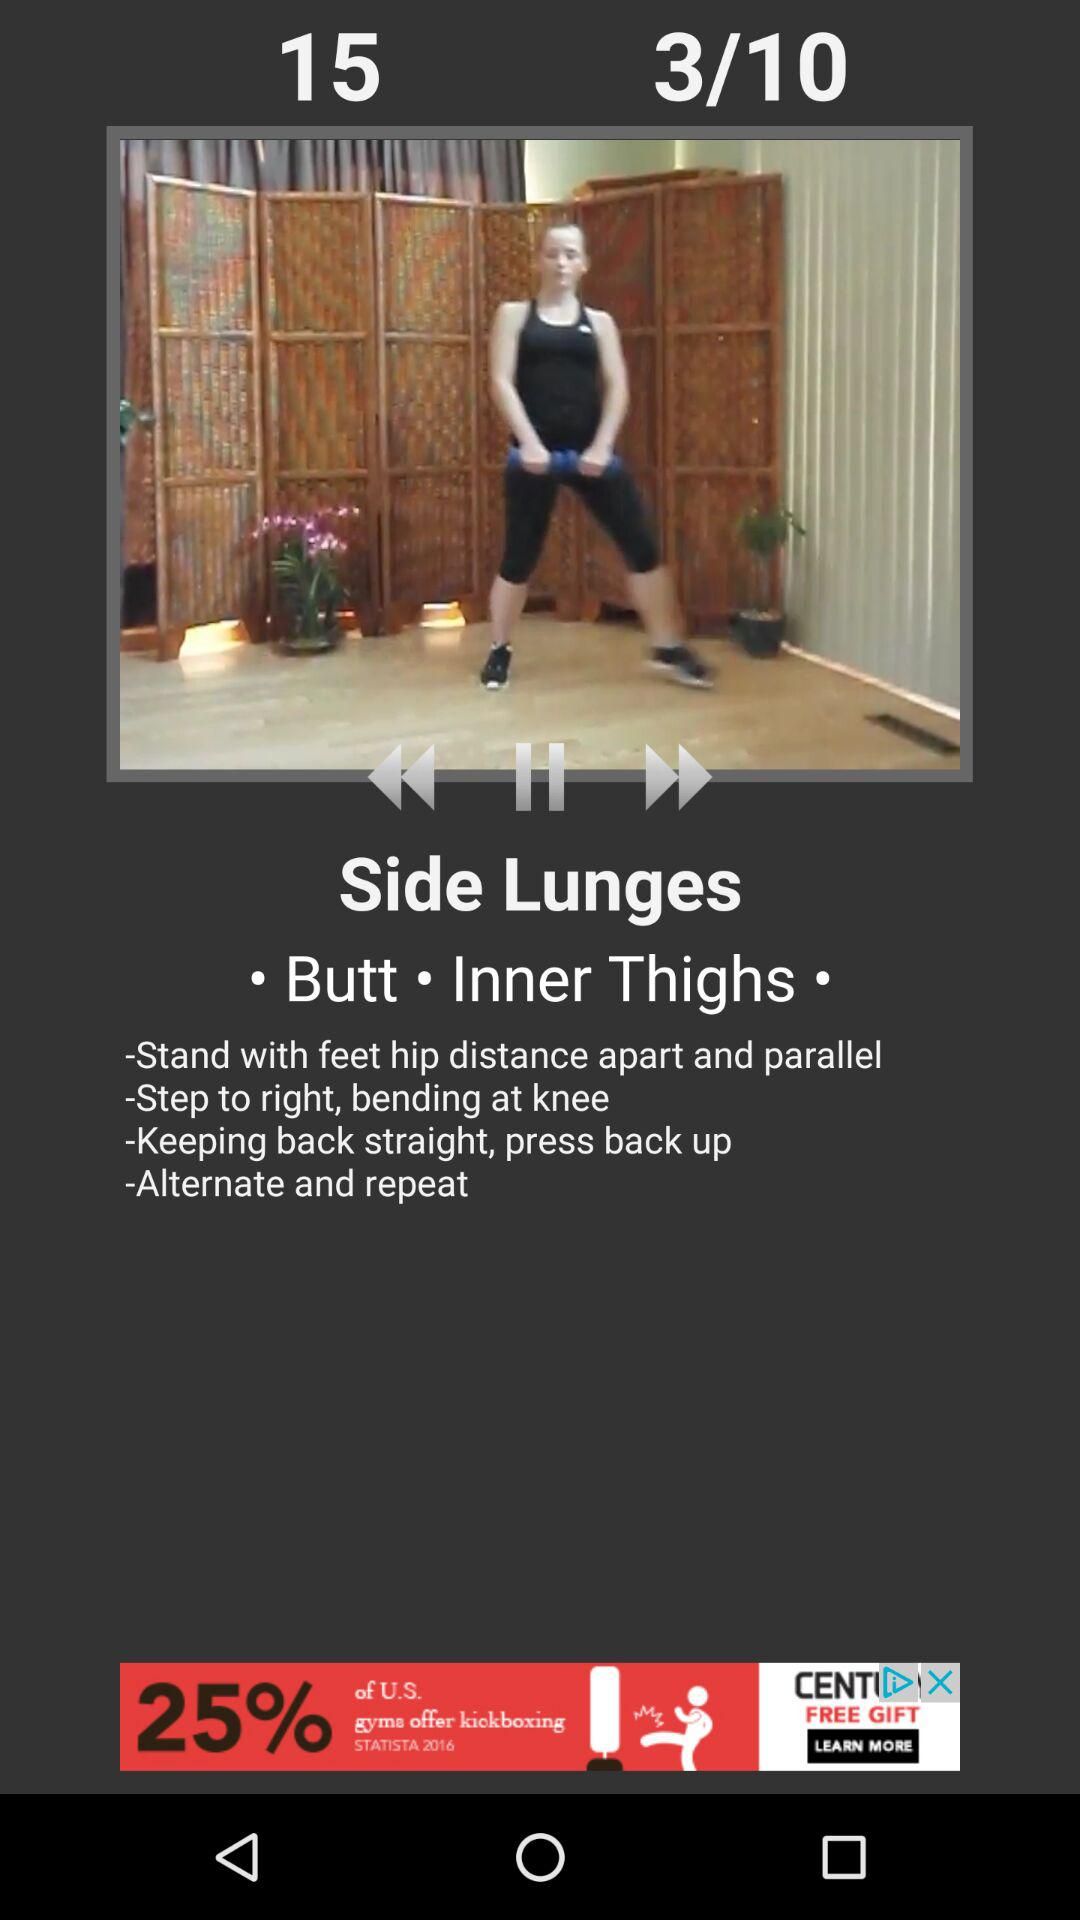How many steps are there in the exercise?
Answer the question using a single word or phrase. 4 